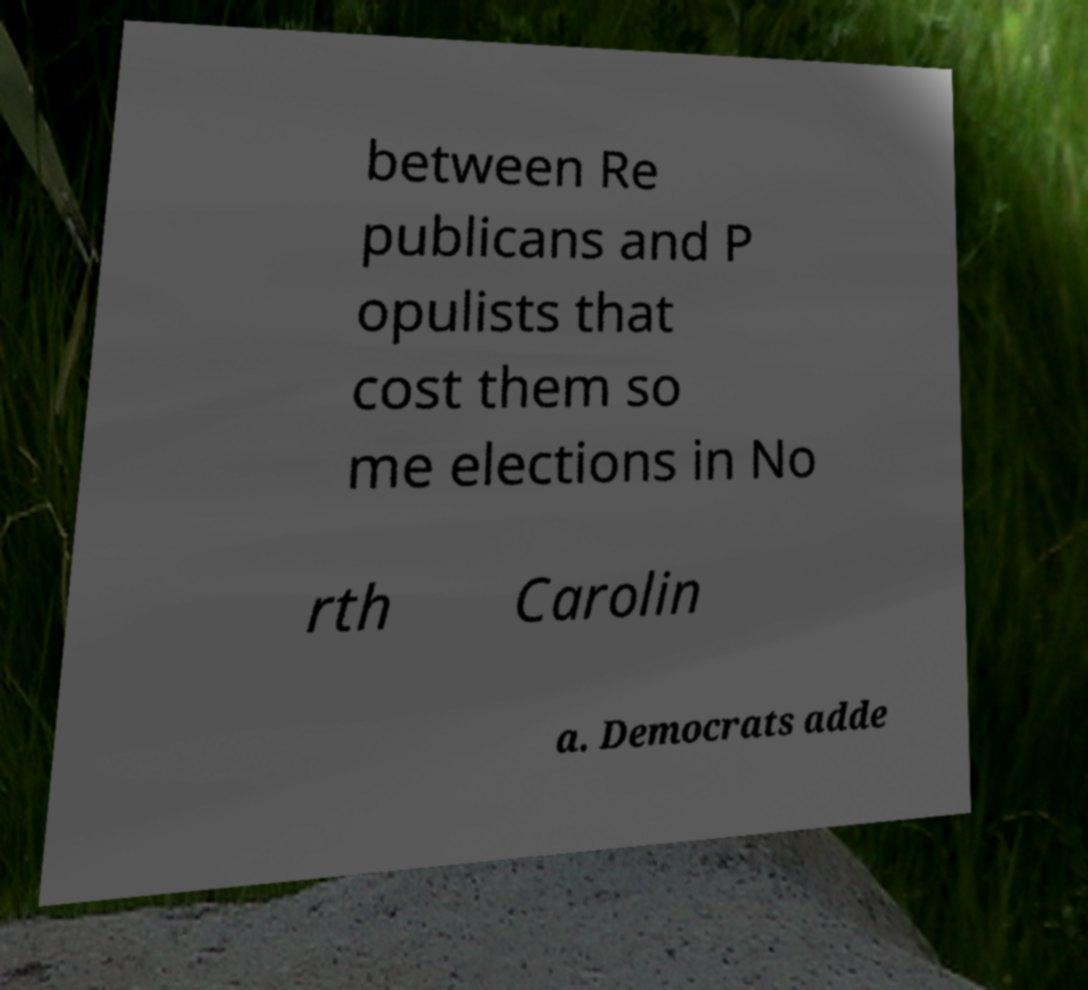What messages or text are displayed in this image? I need them in a readable, typed format. between Re publicans and P opulists that cost them so me elections in No rth Carolin a. Democrats adde 